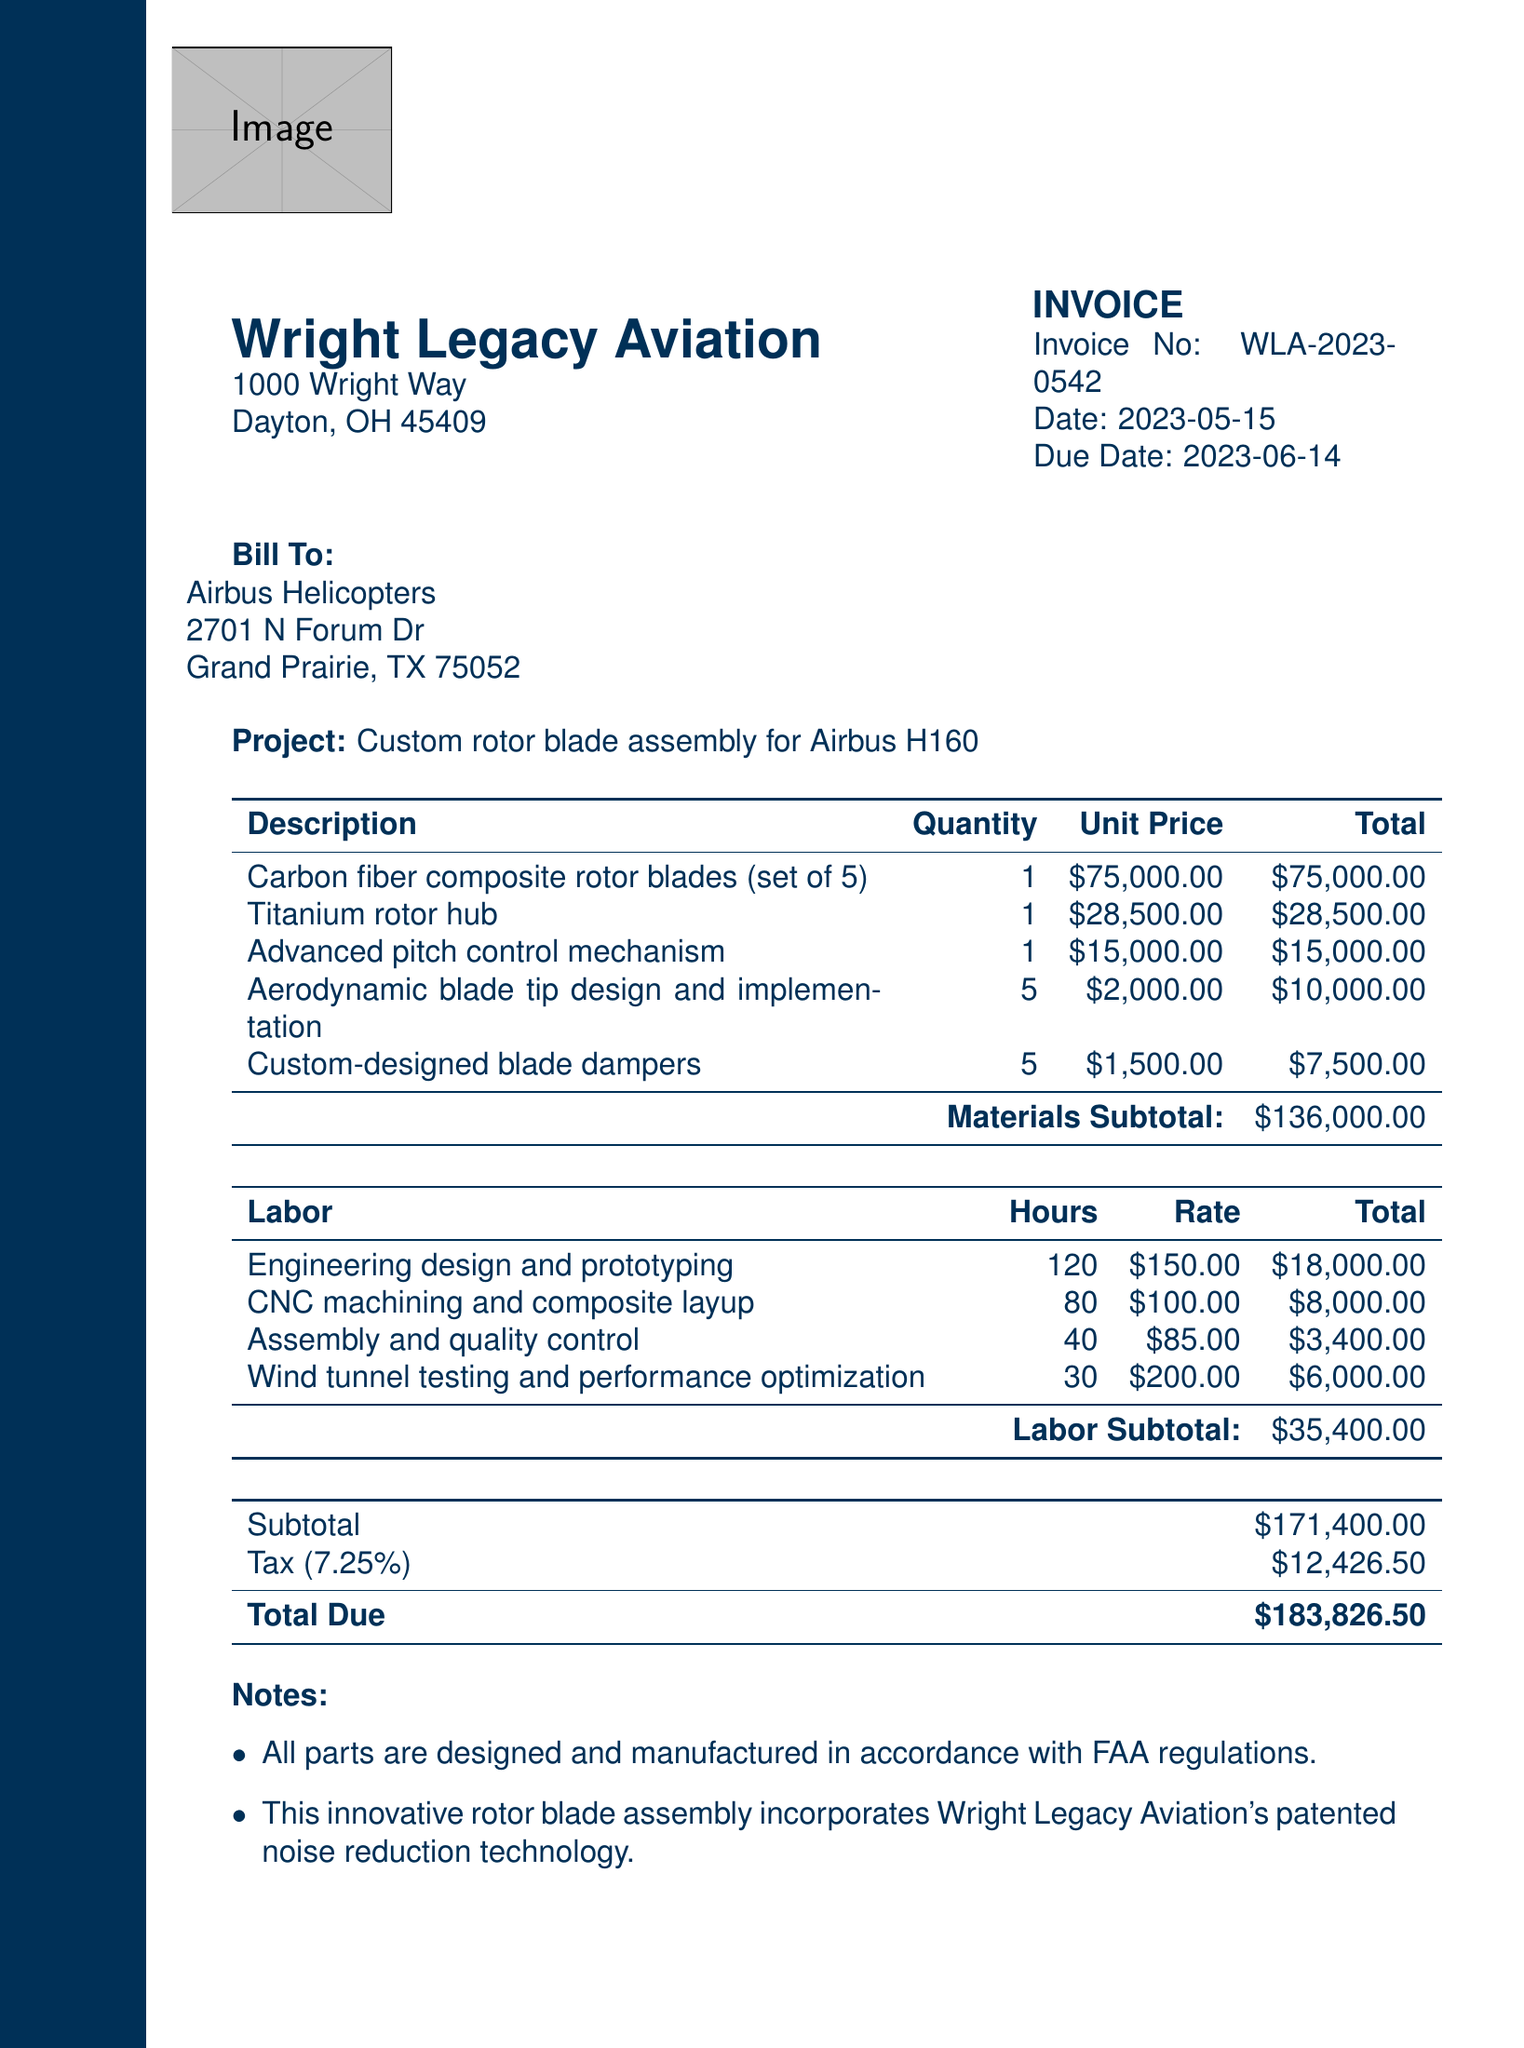What is the invoice number? The invoice number is listed at the top of the document for identification purposes.
Answer: WLA-2023-0542 Who is the customer? The customer is mentioned in the billing section of the document.
Answer: Airbus Helicopters What is the total amount due? The total amount due is calculated at the bottom of the invoice after all costs and taxes are accounted for.
Answer: $183,826.50 What is the date of the invoice? The date the invoice was issued is stated below the invoice number.
Answer: 2023-05-15 How many hours were billed for engineering design and prototyping? The number of hours for this labor category is listed in the labor section of the document.
Answer: 120 What is the subtotal for materials? The subtotal for materials is specified in the materials table before tax is added.
Answer: $136,000.00 What payment methods are accepted? The acceptable payment methods are outlined in the payment section of the document.
Answer: Wire transfer, Company check What is included with all manufactured components? A specific feature or guarantee provided with the components is mentioned in the notes section.
Answer: 10-year warranty What is the tax rate applied to the subtotal? The tax rate is indicated in the section where the tax amount is calculated.
Answer: 7.25% 